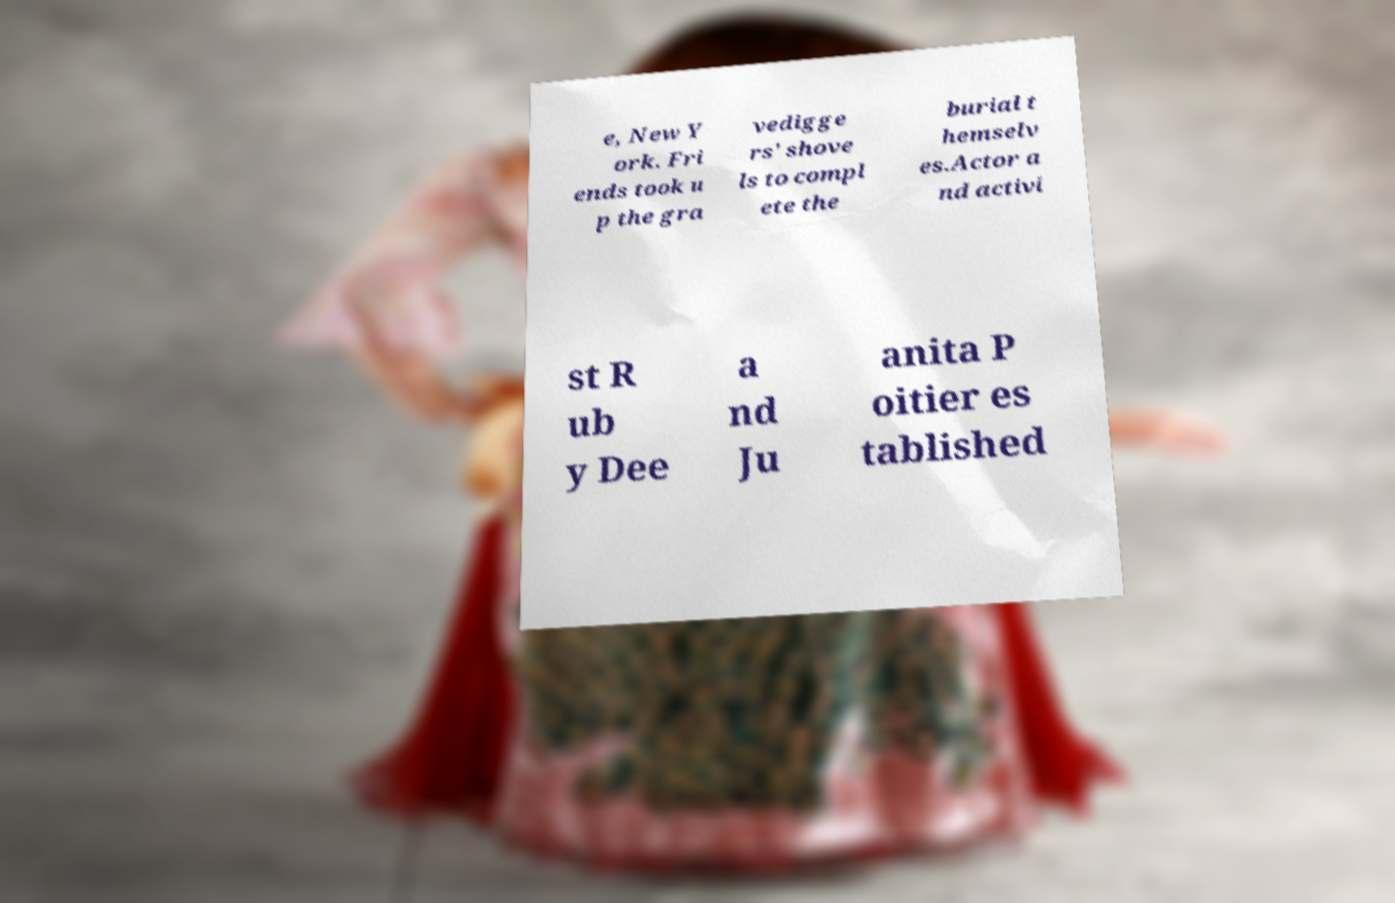I need the written content from this picture converted into text. Can you do that? e, New Y ork. Fri ends took u p the gra vedigge rs' shove ls to compl ete the burial t hemselv es.Actor a nd activi st R ub y Dee a nd Ju anita P oitier es tablished 